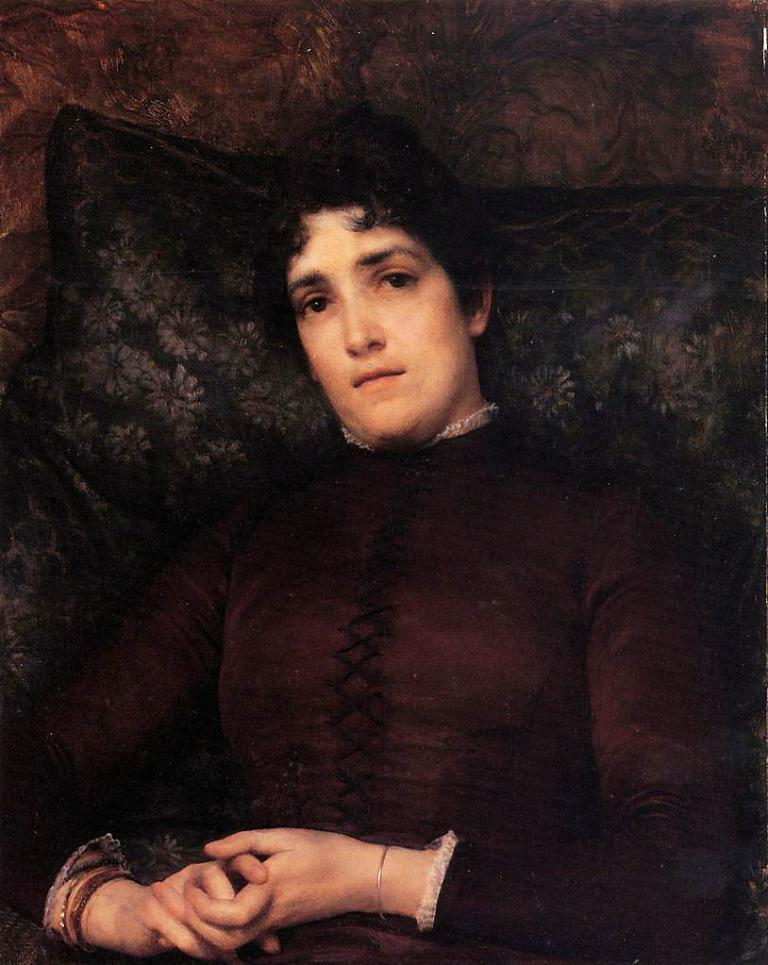What is present in the image? There is a person in the image. Can you describe any objects or elements in the background of the image? There is a pillow visible in the background of the image. What type of line can be seen connecting the person to the beast in the image? There is no beast present in the image, and therefore no line connecting the person to a beast. 